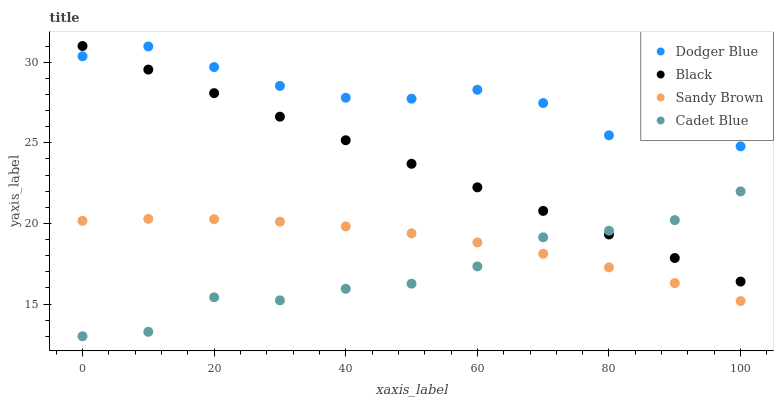Does Cadet Blue have the minimum area under the curve?
Answer yes or no. Yes. Does Dodger Blue have the maximum area under the curve?
Answer yes or no. Yes. Does Dodger Blue have the minimum area under the curve?
Answer yes or no. No. Does Cadet Blue have the maximum area under the curve?
Answer yes or no. No. Is Black the smoothest?
Answer yes or no. Yes. Is Dodger Blue the roughest?
Answer yes or no. Yes. Is Cadet Blue the smoothest?
Answer yes or no. No. Is Cadet Blue the roughest?
Answer yes or no. No. Does Cadet Blue have the lowest value?
Answer yes or no. Yes. Does Dodger Blue have the lowest value?
Answer yes or no. No. Does Black have the highest value?
Answer yes or no. Yes. Does Cadet Blue have the highest value?
Answer yes or no. No. Is Sandy Brown less than Dodger Blue?
Answer yes or no. Yes. Is Dodger Blue greater than Cadet Blue?
Answer yes or no. Yes. Does Cadet Blue intersect Black?
Answer yes or no. Yes. Is Cadet Blue less than Black?
Answer yes or no. No. Is Cadet Blue greater than Black?
Answer yes or no. No. Does Sandy Brown intersect Dodger Blue?
Answer yes or no. No. 